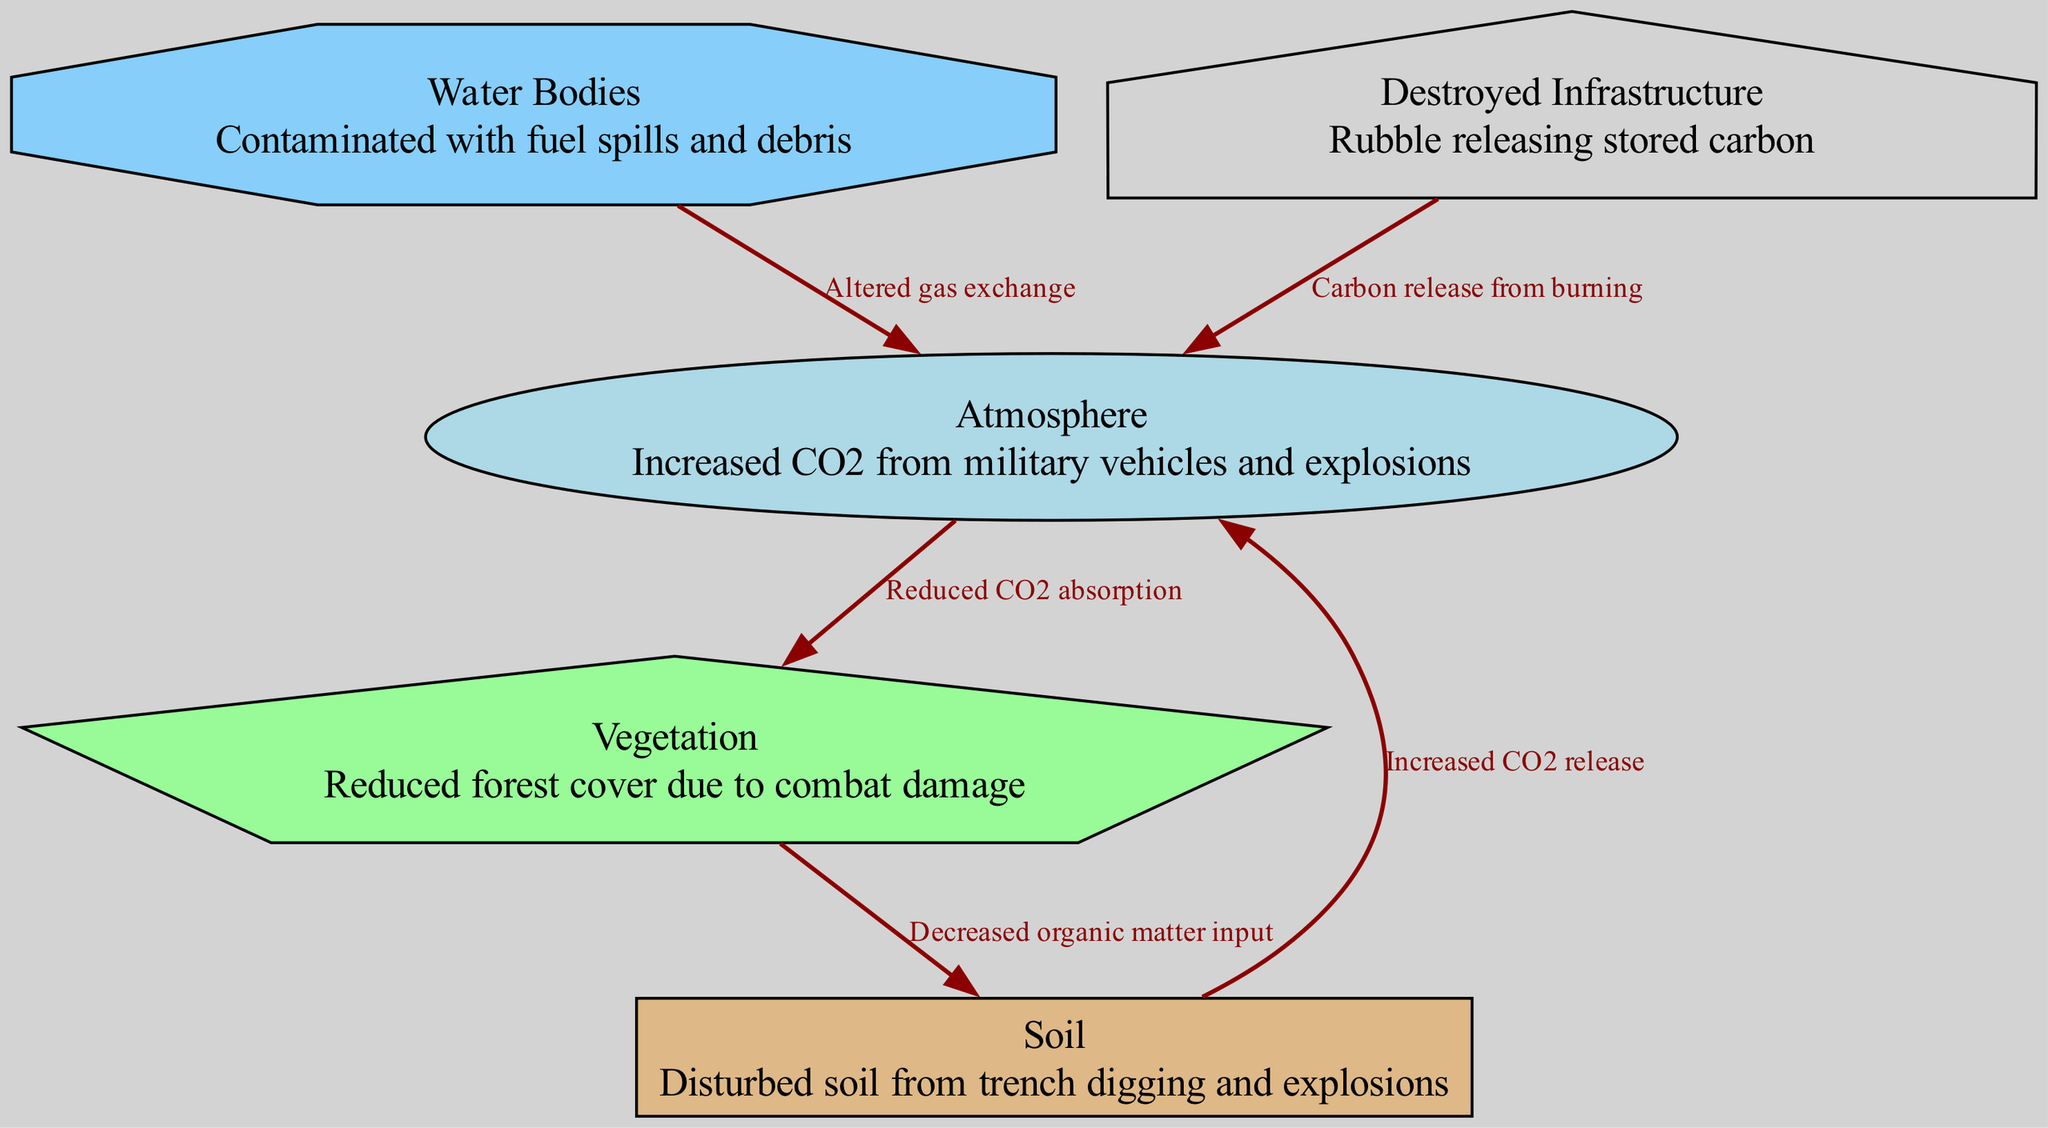How many nodes are in the diagram? Counting the visual representations labeled as nodes, we identify five distinct entities: Atmosphere, Vegetation, Soil, Water Bodies, and Destroyed Infrastructure.
Answer: 5 What is the relationship between the atmosphere and vegetation? According to the edge connecting these two nodes, the atmosphere contributes to reduced CO2 absorption by vegetation. This suggests that increased CO2 in the atmosphere negatively affects the vegetation's ability to absorb CO2.
Answer: Reduced CO2 absorption What does the water bodies node indicate in connection with the atmosphere? The connection shows that water bodies alter gas exchange, affecting the atmosphere. This means that the condition of water bodies can influence the gaseous composition of the atmosphere.
Answer: Altered gas exchange What impact does vegetation have on soil? The edge between vegetation and soil indicates that vegetation contributes to decreased organic matter input into the soil. This implies that damage or reduction in vegetation leads to less organic matter being added to the soil.
Answer: Decreased organic matter input How is carbon released back into the atmosphere from destroyed infrastructure? The connection indicates that carbon is released into the atmosphere from burning destroyed infrastructure. This relation points out that any remnants of infrastructure that burn contribute additional CO2 levels into the atmosphere.
Answer: Carbon release from burning What effect does disturbed soil have on the atmosphere? The edge between soil and atmosphere shows that disturbed soil causes increased CO2 release into the atmosphere, indicating that activities that disturb the soil elevate carbon levels in the air.
Answer: Increased CO2 release What processes contaminate water bodies in a war-torn area? The mention of water bodies suggests that contamination occurs due to fuel spills and debris. These occurrences are likely the result of military activities in the vicinity, leading to compromised water quality.
Answer: Contaminated with fuel spills and debris Which node indicates damage due to military activities? The vegetation node indicates reduced forest cover due to combat damage. This shows a direct consequence of military actions on the local environment, affecting carbon cycle dynamics.
Answer: Reduced forest cover due to combat damage What does the soil node represent in the context of military activities? The soil node represents disturbed soil from trench digging and explosions, highlighting how military operations disrupt the natural state of the land and affect ecological processes.
Answer: Disturbed soil from trench digging and explosions 